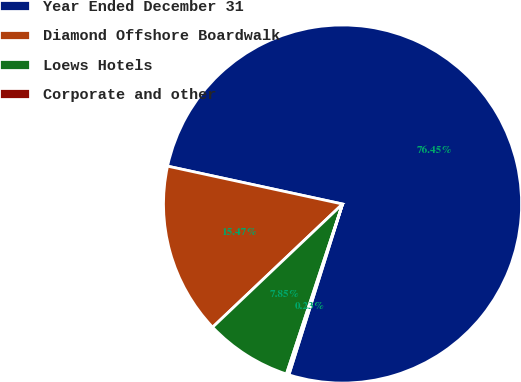Convert chart. <chart><loc_0><loc_0><loc_500><loc_500><pie_chart><fcel>Year Ended December 31<fcel>Diamond Offshore Boardwalk<fcel>Loews Hotels<fcel>Corporate and other<nl><fcel>76.45%<fcel>15.47%<fcel>7.85%<fcel>0.23%<nl></chart> 